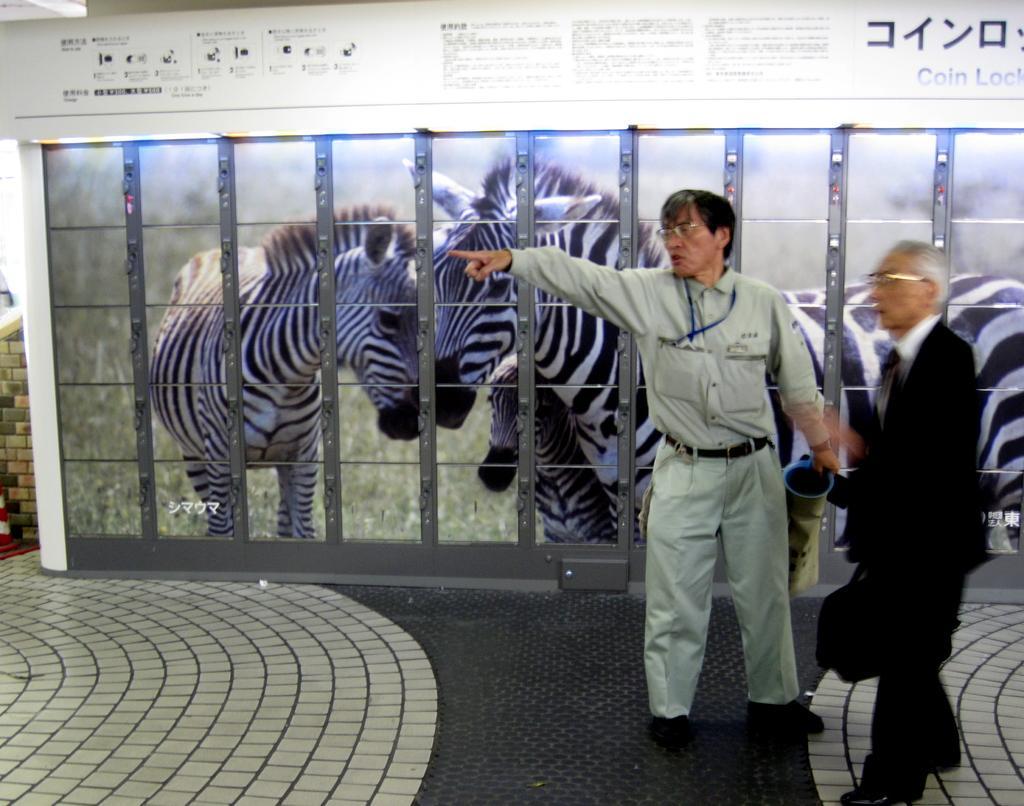Can you describe this image briefly? In the foreground of the image there are two people standing. In the background of the image there is a poster of zebras. At the bottom of the image there is floor. 